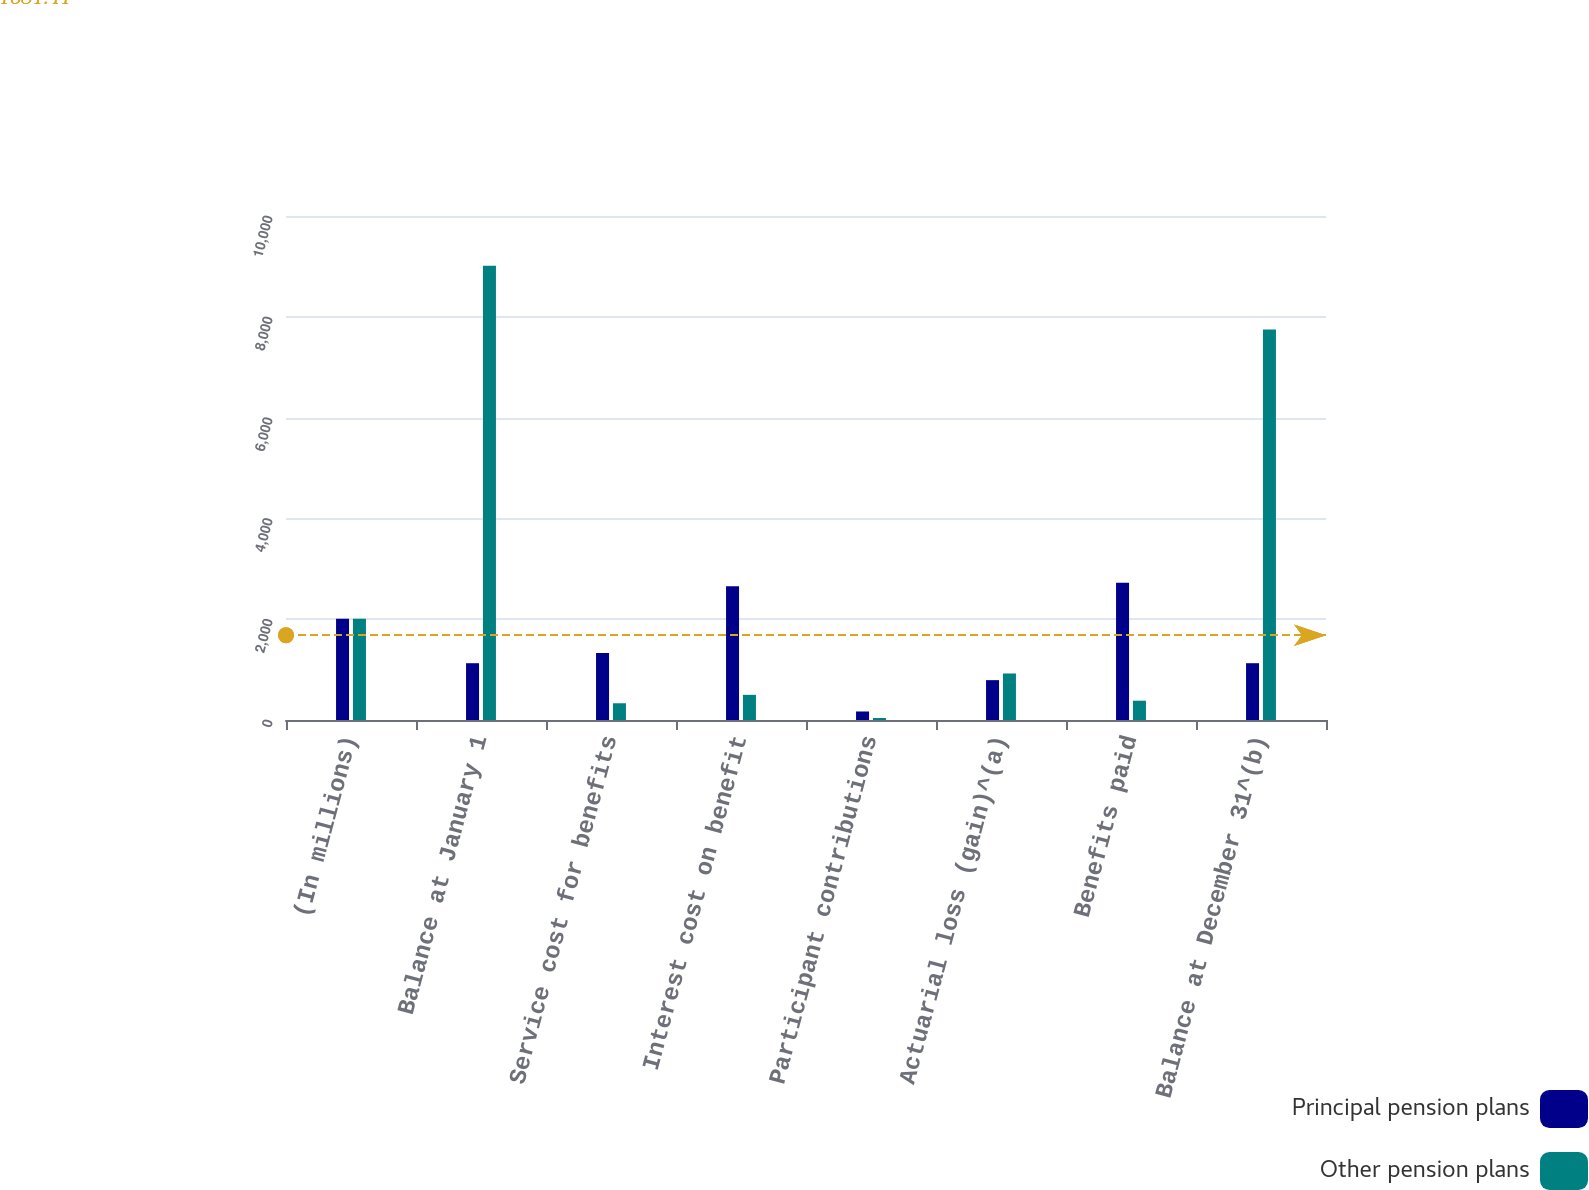<chart> <loc_0><loc_0><loc_500><loc_500><stacked_bar_chart><ecel><fcel>(In millions)<fcel>Balance at January 1<fcel>Service cost for benefits<fcel>Interest cost on benefit<fcel>Participant contributions<fcel>Actuarial loss (gain)^(a)<fcel>Benefits paid<fcel>Balance at December 31^(b)<nl><fcel>Principal pension plans<fcel>2008<fcel>1127<fcel>1331<fcel>2653<fcel>169<fcel>791<fcel>2723<fcel>1127<nl><fcel>Other pension plans<fcel>2008<fcel>9014<fcel>332<fcel>499<fcel>40<fcel>923<fcel>383<fcel>7748<nl></chart> 